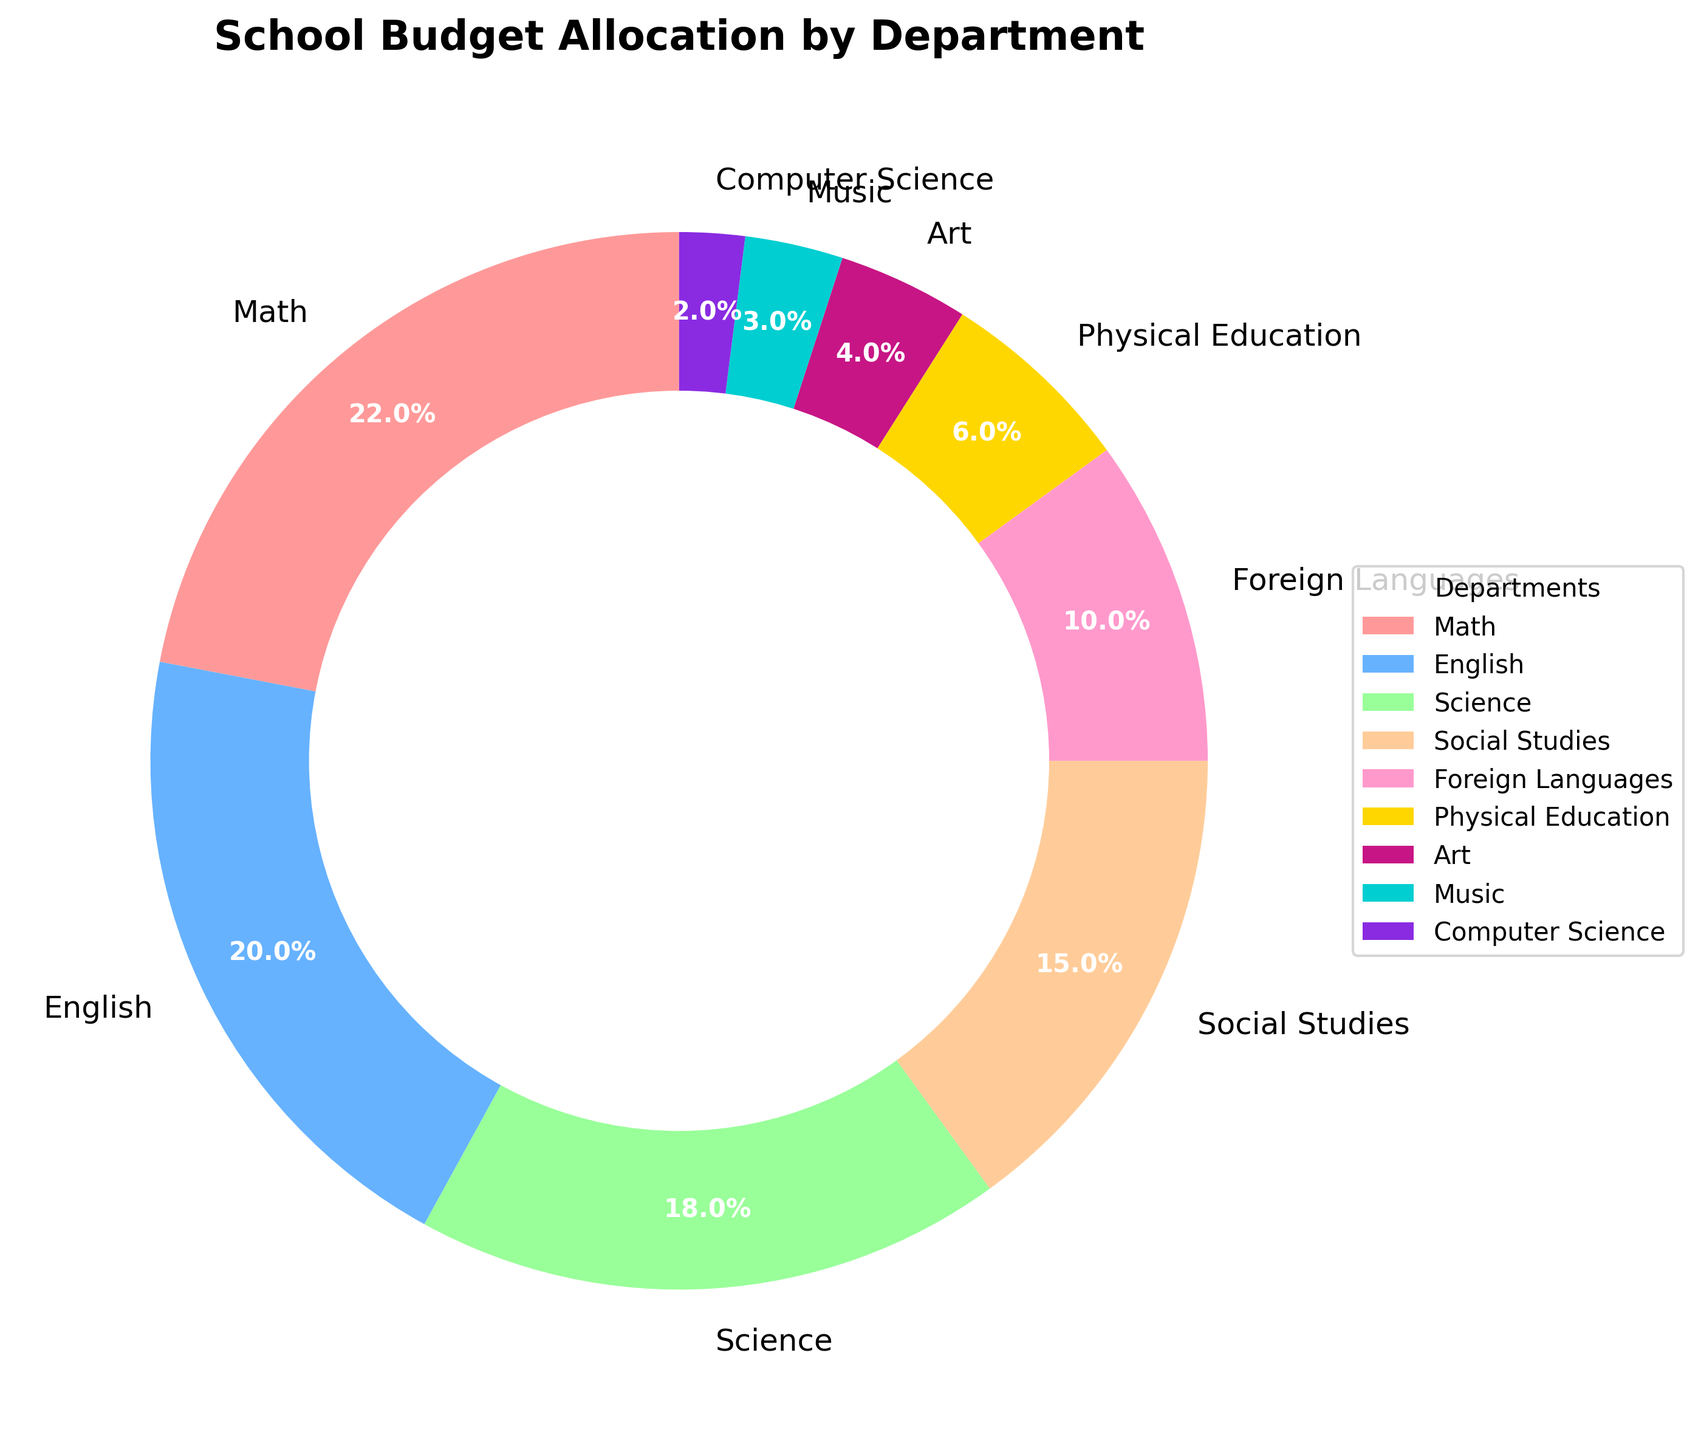What's the total budget allocation percentage for Math and Science? To find the total budget allocation percentage for Math and Science, sum their respective percentages: Math (22%) + Science (18%) = 40%.
Answer: 40% Which department has a higher budget allocation: Social Studies or Foreign Languages? Compare the budget allocation percentages of Social Studies (15%) and Foreign Languages (10%). Social Studies has a higher allocation.
Answer: Social Studies What's the difference in budget allocation between English and Art? Subtract the budget allocation percentage of Art (4%) from that of English (20%): 20% - 4% = 16%.
Answer: 16% What's the sum of the budget allocations for departments with percentages of 10% or less? Summing the budget allocation percentages for Foreign Languages (10%), Physical Education (6%), Art (4%), Music (3%), and Computer Science (2%): 10% + 6% + 4% + 3% + 2% = 25%.
Answer: 25% Which department has the smallest budget allocation, and what is its percentage? Look for the department with the smallest slice in the pie chart. Computer Science has the smallest budget allocation with 2%.
Answer: Computer Science, 2% What's the total budget allocation percentage for departments involved in creative arts (Art and Music)? Add the budget allocation percentages for Art (4%) and Music (3%): 4% + 3% = 7%.
Answer: 7% What's the combined budget allocation for academic subjects (Math, English, Science, Social Studies, and Foreign Languages)? Summing the budget allocation percentages for Math (22%), English (20%), Science (18%), Social Studies (15%), and Foreign Languages (10%): 22% + 20% + 18% + 15% + 10% = 85%.
Answer: 85% Which department has the second highest budget allocation and what is its percentage? Identify the department with the second largest slice in the pie chart, which is English with a budget allocation of 20%.
Answer: English, 20% 